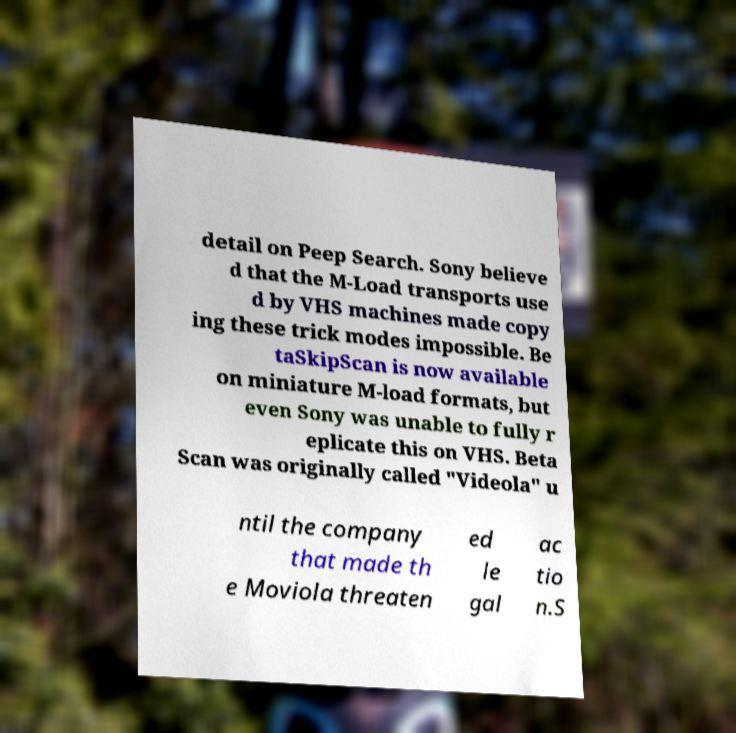For documentation purposes, I need the text within this image transcribed. Could you provide that? detail on Peep Search. Sony believe d that the M-Load transports use d by VHS machines made copy ing these trick modes impossible. Be taSkipScan is now available on miniature M-load formats, but even Sony was unable to fully r eplicate this on VHS. Beta Scan was originally called "Videola" u ntil the company that made th e Moviola threaten ed le gal ac tio n.S 